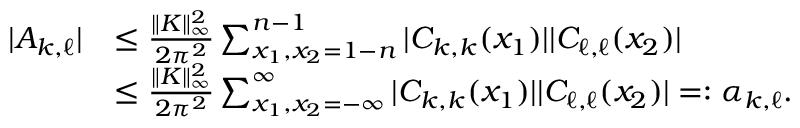Convert formula to latex. <formula><loc_0><loc_0><loc_500><loc_500>\begin{array} { r l } { | A _ { k , \ell } | } & { \leq \frac { \| K \| _ { \infty } ^ { 2 } } { 2 \pi ^ { 2 } } \sum _ { x _ { 1 } , x _ { 2 } = 1 - n } ^ { n - 1 } | C _ { k , k } ( x _ { 1 } ) | | C _ { \ell , \ell } ( x _ { 2 } ) | } \\ & { \leq \frac { \| K \| _ { \infty } ^ { 2 } } { 2 \pi ^ { 2 } } \sum _ { x _ { 1 } , x _ { 2 } = - \infty } ^ { \infty } | C _ { k , k } ( x _ { 1 } ) | | C _ { \ell , \ell } ( x _ { 2 } ) | = \colon \alpha _ { k , \ell } . } \end{array}</formula> 